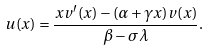Convert formula to latex. <formula><loc_0><loc_0><loc_500><loc_500>u ( x ) = \frac { x v ^ { \prime } ( x ) - ( \alpha + \gamma x ) v ( x ) } { \beta - \sigma \lambda } .</formula> 